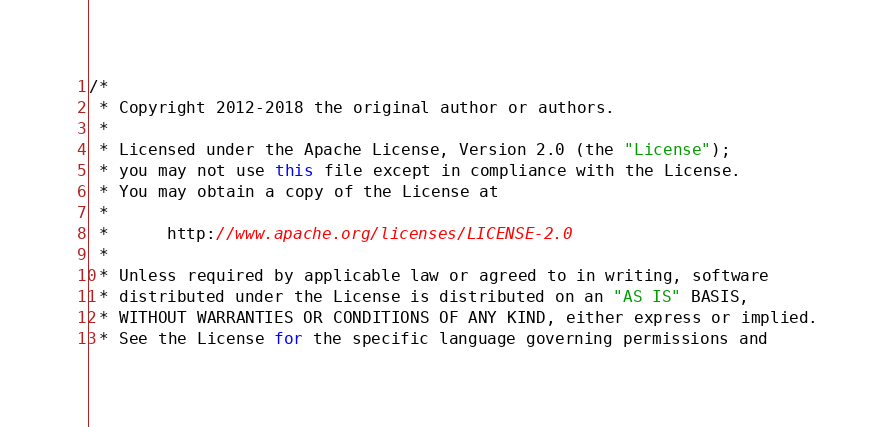<code> <loc_0><loc_0><loc_500><loc_500><_Java_>/*
 * Copyright 2012-2018 the original author or authors.
 *
 * Licensed under the Apache License, Version 2.0 (the "License");
 * you may not use this file except in compliance with the License.
 * You may obtain a copy of the License at
 *
 *      http://www.apache.org/licenses/LICENSE-2.0
 *
 * Unless required by applicable law or agreed to in writing, software
 * distributed under the License is distributed on an "AS IS" BASIS,
 * WITHOUT WARRANTIES OR CONDITIONS OF ANY KIND, either express or implied.
 * See the License for the specific language governing permissions and</code> 